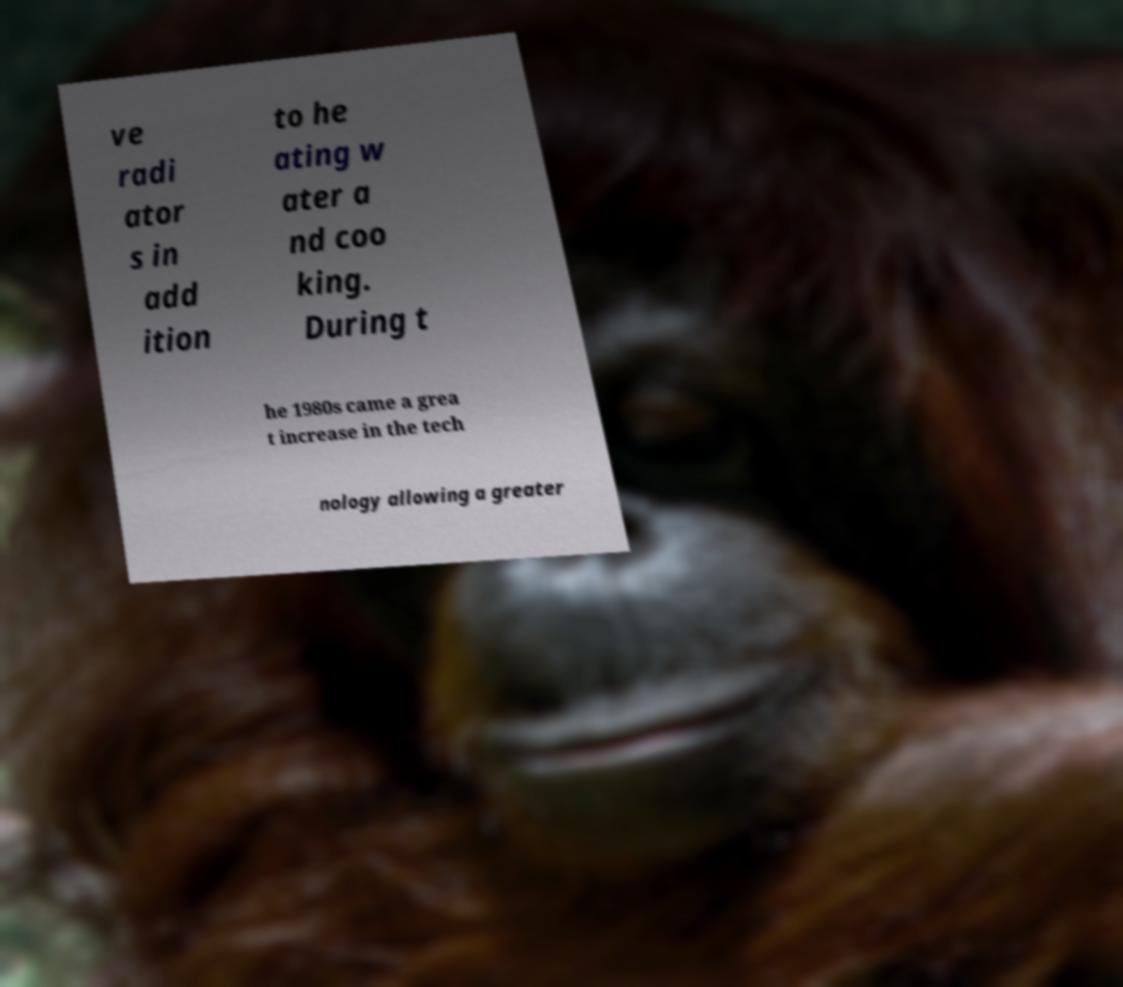Please identify and transcribe the text found in this image. ve radi ator s in add ition to he ating w ater a nd coo king. During t he 1980s came a grea t increase in the tech nology allowing a greater 